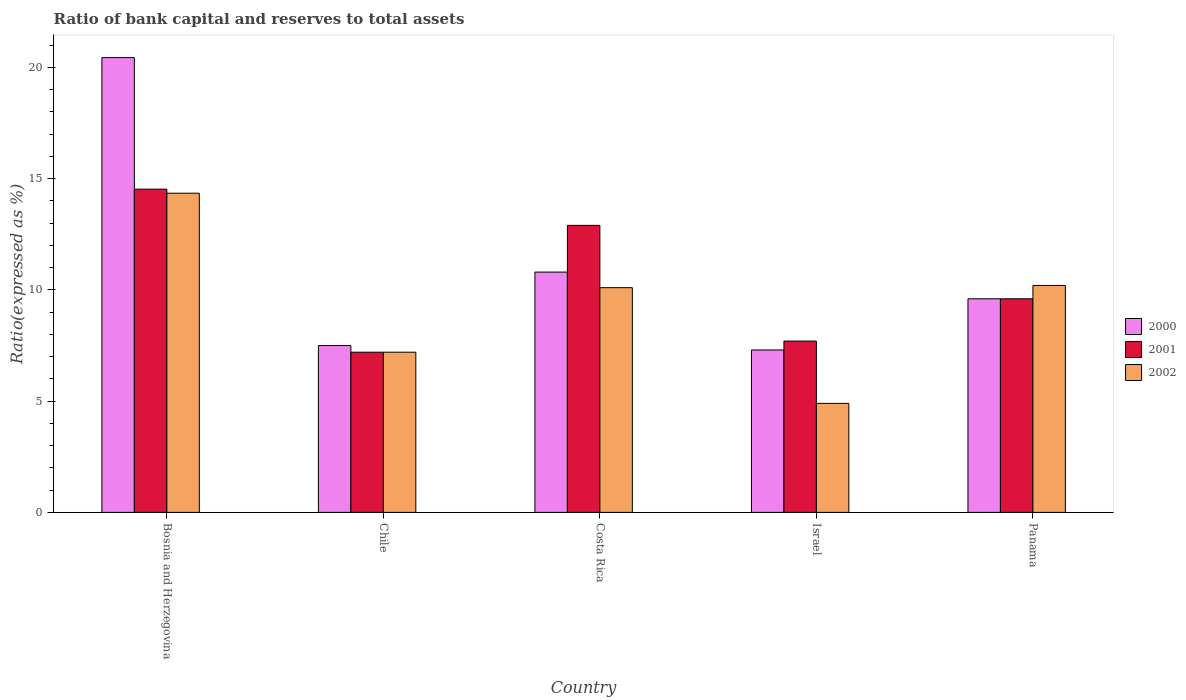How many groups of bars are there?
Your answer should be compact. 5. How many bars are there on the 4th tick from the right?
Make the answer very short. 3. What is the label of the 1st group of bars from the left?
Offer a terse response. Bosnia and Herzegovina. In how many cases, is the number of bars for a given country not equal to the number of legend labels?
Your answer should be very brief. 0. Across all countries, what is the maximum ratio of bank capital and reserves to total assets in 2002?
Provide a succinct answer. 14.35. In which country was the ratio of bank capital and reserves to total assets in 2002 maximum?
Ensure brevity in your answer.  Bosnia and Herzegovina. In which country was the ratio of bank capital and reserves to total assets in 2001 minimum?
Your response must be concise. Chile. What is the total ratio of bank capital and reserves to total assets in 2002 in the graph?
Make the answer very short. 46.75. What is the difference between the ratio of bank capital and reserves to total assets in 2000 in Bosnia and Herzegovina and that in Israel?
Your response must be concise. 13.14. What is the difference between the ratio of bank capital and reserves to total assets in 2000 in Israel and the ratio of bank capital and reserves to total assets in 2002 in Costa Rica?
Provide a succinct answer. -2.8. What is the average ratio of bank capital and reserves to total assets in 2002 per country?
Offer a very short reply. 9.35. What is the difference between the ratio of bank capital and reserves to total assets of/in 2001 and ratio of bank capital and reserves to total assets of/in 2002 in Bosnia and Herzegovina?
Provide a succinct answer. 0.18. In how many countries, is the ratio of bank capital and reserves to total assets in 2002 greater than 13 %?
Your answer should be compact. 1. What is the ratio of the ratio of bank capital and reserves to total assets in 2000 in Costa Rica to that in Israel?
Provide a short and direct response. 1.48. Is the ratio of bank capital and reserves to total assets in 2001 in Bosnia and Herzegovina less than that in Panama?
Provide a short and direct response. No. What is the difference between the highest and the second highest ratio of bank capital and reserves to total assets in 2000?
Offer a very short reply. -1.2. What is the difference between the highest and the lowest ratio of bank capital and reserves to total assets in 2000?
Give a very brief answer. 13.14. What does the 2nd bar from the right in Bosnia and Herzegovina represents?
Your response must be concise. 2001. Are all the bars in the graph horizontal?
Provide a short and direct response. No. How many countries are there in the graph?
Make the answer very short. 5. Does the graph contain grids?
Keep it short and to the point. No. Where does the legend appear in the graph?
Provide a short and direct response. Center right. How many legend labels are there?
Provide a succinct answer. 3. What is the title of the graph?
Keep it short and to the point. Ratio of bank capital and reserves to total assets. Does "1978" appear as one of the legend labels in the graph?
Provide a short and direct response. No. What is the label or title of the X-axis?
Offer a very short reply. Country. What is the label or title of the Y-axis?
Your response must be concise. Ratio(expressed as %). What is the Ratio(expressed as %) in 2000 in Bosnia and Herzegovina?
Ensure brevity in your answer.  20.44. What is the Ratio(expressed as %) in 2001 in Bosnia and Herzegovina?
Provide a succinct answer. 14.53. What is the Ratio(expressed as %) of 2002 in Bosnia and Herzegovina?
Your response must be concise. 14.35. What is the Ratio(expressed as %) in 2000 in Chile?
Make the answer very short. 7.5. What is the Ratio(expressed as %) of 2002 in Chile?
Keep it short and to the point. 7.2. What is the Ratio(expressed as %) in 2002 in Costa Rica?
Ensure brevity in your answer.  10.1. What is the Ratio(expressed as %) of 2002 in Israel?
Your response must be concise. 4.9. What is the Ratio(expressed as %) in 2000 in Panama?
Keep it short and to the point. 9.6. Across all countries, what is the maximum Ratio(expressed as %) in 2000?
Make the answer very short. 20.44. Across all countries, what is the maximum Ratio(expressed as %) in 2001?
Your answer should be compact. 14.53. Across all countries, what is the maximum Ratio(expressed as %) in 2002?
Your answer should be very brief. 14.35. Across all countries, what is the minimum Ratio(expressed as %) of 2001?
Ensure brevity in your answer.  7.2. What is the total Ratio(expressed as %) in 2000 in the graph?
Your response must be concise. 55.64. What is the total Ratio(expressed as %) of 2001 in the graph?
Offer a terse response. 51.93. What is the total Ratio(expressed as %) of 2002 in the graph?
Your response must be concise. 46.75. What is the difference between the Ratio(expressed as %) in 2000 in Bosnia and Herzegovina and that in Chile?
Provide a short and direct response. 12.94. What is the difference between the Ratio(expressed as %) in 2001 in Bosnia and Herzegovina and that in Chile?
Your response must be concise. 7.33. What is the difference between the Ratio(expressed as %) in 2002 in Bosnia and Herzegovina and that in Chile?
Your response must be concise. 7.15. What is the difference between the Ratio(expressed as %) of 2000 in Bosnia and Herzegovina and that in Costa Rica?
Your answer should be compact. 9.64. What is the difference between the Ratio(expressed as %) in 2001 in Bosnia and Herzegovina and that in Costa Rica?
Make the answer very short. 1.63. What is the difference between the Ratio(expressed as %) of 2002 in Bosnia and Herzegovina and that in Costa Rica?
Provide a short and direct response. 4.25. What is the difference between the Ratio(expressed as %) of 2000 in Bosnia and Herzegovina and that in Israel?
Offer a terse response. 13.14. What is the difference between the Ratio(expressed as %) in 2001 in Bosnia and Herzegovina and that in Israel?
Your answer should be compact. 6.83. What is the difference between the Ratio(expressed as %) of 2002 in Bosnia and Herzegovina and that in Israel?
Provide a short and direct response. 9.45. What is the difference between the Ratio(expressed as %) in 2000 in Bosnia and Herzegovina and that in Panama?
Give a very brief answer. 10.84. What is the difference between the Ratio(expressed as %) of 2001 in Bosnia and Herzegovina and that in Panama?
Offer a very short reply. 4.93. What is the difference between the Ratio(expressed as %) in 2002 in Bosnia and Herzegovina and that in Panama?
Keep it short and to the point. 4.15. What is the difference between the Ratio(expressed as %) of 2000 in Chile and that in Costa Rica?
Your answer should be compact. -3.3. What is the difference between the Ratio(expressed as %) in 2001 in Chile and that in Costa Rica?
Your answer should be very brief. -5.7. What is the difference between the Ratio(expressed as %) in 2002 in Chile and that in Costa Rica?
Provide a succinct answer. -2.9. What is the difference between the Ratio(expressed as %) in 2001 in Chile and that in Israel?
Your answer should be very brief. -0.5. What is the difference between the Ratio(expressed as %) of 2002 in Chile and that in Israel?
Your answer should be very brief. 2.3. What is the difference between the Ratio(expressed as %) in 2002 in Chile and that in Panama?
Offer a terse response. -3. What is the difference between the Ratio(expressed as %) of 2000 in Costa Rica and that in Israel?
Your answer should be very brief. 3.5. What is the difference between the Ratio(expressed as %) of 2001 in Costa Rica and that in Israel?
Offer a terse response. 5.2. What is the difference between the Ratio(expressed as %) of 2002 in Costa Rica and that in Israel?
Give a very brief answer. 5.2. What is the difference between the Ratio(expressed as %) of 2000 in Costa Rica and that in Panama?
Give a very brief answer. 1.2. What is the difference between the Ratio(expressed as %) in 2002 in Costa Rica and that in Panama?
Keep it short and to the point. -0.1. What is the difference between the Ratio(expressed as %) of 2001 in Israel and that in Panama?
Provide a succinct answer. -1.9. What is the difference between the Ratio(expressed as %) of 2000 in Bosnia and Herzegovina and the Ratio(expressed as %) of 2001 in Chile?
Provide a succinct answer. 13.24. What is the difference between the Ratio(expressed as %) of 2000 in Bosnia and Herzegovina and the Ratio(expressed as %) of 2002 in Chile?
Your answer should be very brief. 13.24. What is the difference between the Ratio(expressed as %) in 2001 in Bosnia and Herzegovina and the Ratio(expressed as %) in 2002 in Chile?
Your response must be concise. 7.33. What is the difference between the Ratio(expressed as %) of 2000 in Bosnia and Herzegovina and the Ratio(expressed as %) of 2001 in Costa Rica?
Offer a very short reply. 7.54. What is the difference between the Ratio(expressed as %) in 2000 in Bosnia and Herzegovina and the Ratio(expressed as %) in 2002 in Costa Rica?
Give a very brief answer. 10.34. What is the difference between the Ratio(expressed as %) in 2001 in Bosnia and Herzegovina and the Ratio(expressed as %) in 2002 in Costa Rica?
Provide a succinct answer. 4.43. What is the difference between the Ratio(expressed as %) in 2000 in Bosnia and Herzegovina and the Ratio(expressed as %) in 2001 in Israel?
Give a very brief answer. 12.74. What is the difference between the Ratio(expressed as %) in 2000 in Bosnia and Herzegovina and the Ratio(expressed as %) in 2002 in Israel?
Provide a short and direct response. 15.54. What is the difference between the Ratio(expressed as %) of 2001 in Bosnia and Herzegovina and the Ratio(expressed as %) of 2002 in Israel?
Keep it short and to the point. 9.63. What is the difference between the Ratio(expressed as %) in 2000 in Bosnia and Herzegovina and the Ratio(expressed as %) in 2001 in Panama?
Provide a short and direct response. 10.84. What is the difference between the Ratio(expressed as %) in 2000 in Bosnia and Herzegovina and the Ratio(expressed as %) in 2002 in Panama?
Give a very brief answer. 10.24. What is the difference between the Ratio(expressed as %) of 2001 in Bosnia and Herzegovina and the Ratio(expressed as %) of 2002 in Panama?
Provide a succinct answer. 4.33. What is the difference between the Ratio(expressed as %) of 2000 in Chile and the Ratio(expressed as %) of 2002 in Costa Rica?
Give a very brief answer. -2.6. What is the difference between the Ratio(expressed as %) of 2001 in Chile and the Ratio(expressed as %) of 2002 in Costa Rica?
Your answer should be compact. -2.9. What is the difference between the Ratio(expressed as %) of 2000 in Chile and the Ratio(expressed as %) of 2002 in Israel?
Offer a terse response. 2.6. What is the difference between the Ratio(expressed as %) in 2001 in Chile and the Ratio(expressed as %) in 2002 in Israel?
Offer a very short reply. 2.3. What is the difference between the Ratio(expressed as %) of 2000 in Chile and the Ratio(expressed as %) of 2001 in Panama?
Give a very brief answer. -2.1. What is the difference between the Ratio(expressed as %) of 2000 in Chile and the Ratio(expressed as %) of 2002 in Panama?
Offer a very short reply. -2.7. What is the difference between the Ratio(expressed as %) of 2000 in Costa Rica and the Ratio(expressed as %) of 2001 in Panama?
Keep it short and to the point. 1.2. What is the difference between the Ratio(expressed as %) in 2001 in Costa Rica and the Ratio(expressed as %) in 2002 in Panama?
Ensure brevity in your answer.  2.7. What is the difference between the Ratio(expressed as %) in 2000 in Israel and the Ratio(expressed as %) in 2001 in Panama?
Provide a short and direct response. -2.3. What is the difference between the Ratio(expressed as %) of 2000 in Israel and the Ratio(expressed as %) of 2002 in Panama?
Your response must be concise. -2.9. What is the difference between the Ratio(expressed as %) of 2001 in Israel and the Ratio(expressed as %) of 2002 in Panama?
Your answer should be very brief. -2.5. What is the average Ratio(expressed as %) of 2000 per country?
Your answer should be compact. 11.13. What is the average Ratio(expressed as %) in 2001 per country?
Your response must be concise. 10.39. What is the average Ratio(expressed as %) in 2002 per country?
Offer a very short reply. 9.35. What is the difference between the Ratio(expressed as %) of 2000 and Ratio(expressed as %) of 2001 in Bosnia and Herzegovina?
Keep it short and to the point. 5.91. What is the difference between the Ratio(expressed as %) in 2000 and Ratio(expressed as %) in 2002 in Bosnia and Herzegovina?
Make the answer very short. 6.09. What is the difference between the Ratio(expressed as %) of 2001 and Ratio(expressed as %) of 2002 in Bosnia and Herzegovina?
Your answer should be very brief. 0.18. What is the difference between the Ratio(expressed as %) in 2000 and Ratio(expressed as %) in 2001 in Israel?
Offer a very short reply. -0.4. What is the difference between the Ratio(expressed as %) in 2000 and Ratio(expressed as %) in 2001 in Panama?
Offer a terse response. 0. What is the difference between the Ratio(expressed as %) in 2001 and Ratio(expressed as %) in 2002 in Panama?
Your response must be concise. -0.6. What is the ratio of the Ratio(expressed as %) of 2000 in Bosnia and Herzegovina to that in Chile?
Your response must be concise. 2.73. What is the ratio of the Ratio(expressed as %) of 2001 in Bosnia and Herzegovina to that in Chile?
Keep it short and to the point. 2.02. What is the ratio of the Ratio(expressed as %) of 2002 in Bosnia and Herzegovina to that in Chile?
Your answer should be compact. 1.99. What is the ratio of the Ratio(expressed as %) in 2000 in Bosnia and Herzegovina to that in Costa Rica?
Provide a succinct answer. 1.89. What is the ratio of the Ratio(expressed as %) of 2001 in Bosnia and Herzegovina to that in Costa Rica?
Offer a very short reply. 1.13. What is the ratio of the Ratio(expressed as %) in 2002 in Bosnia and Herzegovina to that in Costa Rica?
Make the answer very short. 1.42. What is the ratio of the Ratio(expressed as %) in 2000 in Bosnia and Herzegovina to that in Israel?
Your answer should be very brief. 2.8. What is the ratio of the Ratio(expressed as %) in 2001 in Bosnia and Herzegovina to that in Israel?
Keep it short and to the point. 1.89. What is the ratio of the Ratio(expressed as %) of 2002 in Bosnia and Herzegovina to that in Israel?
Offer a terse response. 2.93. What is the ratio of the Ratio(expressed as %) of 2000 in Bosnia and Herzegovina to that in Panama?
Ensure brevity in your answer.  2.13. What is the ratio of the Ratio(expressed as %) in 2001 in Bosnia and Herzegovina to that in Panama?
Your response must be concise. 1.51. What is the ratio of the Ratio(expressed as %) in 2002 in Bosnia and Herzegovina to that in Panama?
Your answer should be very brief. 1.41. What is the ratio of the Ratio(expressed as %) in 2000 in Chile to that in Costa Rica?
Give a very brief answer. 0.69. What is the ratio of the Ratio(expressed as %) in 2001 in Chile to that in Costa Rica?
Your answer should be very brief. 0.56. What is the ratio of the Ratio(expressed as %) of 2002 in Chile to that in Costa Rica?
Your answer should be very brief. 0.71. What is the ratio of the Ratio(expressed as %) in 2000 in Chile to that in Israel?
Provide a short and direct response. 1.03. What is the ratio of the Ratio(expressed as %) of 2001 in Chile to that in Israel?
Your answer should be very brief. 0.94. What is the ratio of the Ratio(expressed as %) of 2002 in Chile to that in Israel?
Keep it short and to the point. 1.47. What is the ratio of the Ratio(expressed as %) of 2000 in Chile to that in Panama?
Give a very brief answer. 0.78. What is the ratio of the Ratio(expressed as %) in 2001 in Chile to that in Panama?
Ensure brevity in your answer.  0.75. What is the ratio of the Ratio(expressed as %) of 2002 in Chile to that in Panama?
Give a very brief answer. 0.71. What is the ratio of the Ratio(expressed as %) in 2000 in Costa Rica to that in Israel?
Your response must be concise. 1.48. What is the ratio of the Ratio(expressed as %) of 2001 in Costa Rica to that in Israel?
Give a very brief answer. 1.68. What is the ratio of the Ratio(expressed as %) of 2002 in Costa Rica to that in Israel?
Your response must be concise. 2.06. What is the ratio of the Ratio(expressed as %) in 2000 in Costa Rica to that in Panama?
Keep it short and to the point. 1.12. What is the ratio of the Ratio(expressed as %) in 2001 in Costa Rica to that in Panama?
Offer a very short reply. 1.34. What is the ratio of the Ratio(expressed as %) in 2002 in Costa Rica to that in Panama?
Make the answer very short. 0.99. What is the ratio of the Ratio(expressed as %) in 2000 in Israel to that in Panama?
Provide a short and direct response. 0.76. What is the ratio of the Ratio(expressed as %) of 2001 in Israel to that in Panama?
Make the answer very short. 0.8. What is the ratio of the Ratio(expressed as %) in 2002 in Israel to that in Panama?
Provide a short and direct response. 0.48. What is the difference between the highest and the second highest Ratio(expressed as %) of 2000?
Give a very brief answer. 9.64. What is the difference between the highest and the second highest Ratio(expressed as %) in 2001?
Offer a terse response. 1.63. What is the difference between the highest and the second highest Ratio(expressed as %) in 2002?
Provide a succinct answer. 4.15. What is the difference between the highest and the lowest Ratio(expressed as %) of 2000?
Give a very brief answer. 13.14. What is the difference between the highest and the lowest Ratio(expressed as %) in 2001?
Provide a short and direct response. 7.33. What is the difference between the highest and the lowest Ratio(expressed as %) of 2002?
Provide a short and direct response. 9.45. 